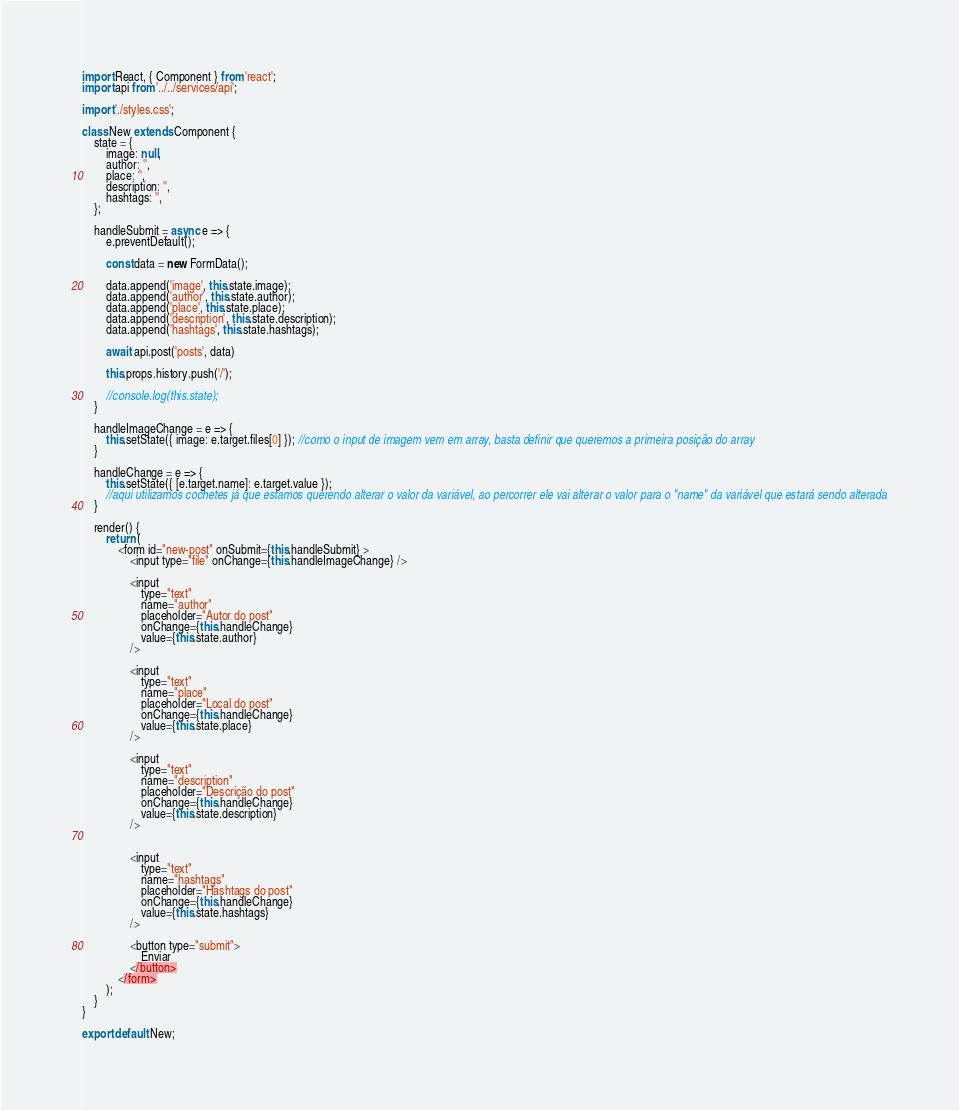Convert code to text. <code><loc_0><loc_0><loc_500><loc_500><_JavaScript_>import React, { Component } from 'react';
import api from '../../services/api';

import './styles.css';

class New extends Component {
    state = {
        image: null,
        author: '',
        place: '',
        description: '',
        hashtags: '',
    };

    handleSubmit = async e => {
        e.preventDefault();

        const data = new FormData();

        data.append('image', this.state.image);
        data.append('author', this.state.author);
        data.append('place', this.state.place);
        data.append('description', this.state.description);
        data.append('hashtags', this.state.hashtags);

        await api.post('posts', data)

        this.props.history.push('/');

        //console.log(this.state);
    }

    handleImageChange = e => {
        this.setState({ image: e.target.files[0] }); //como o input de imagem vem em array, basta definir que queremos a primeira posição do array
    }

    handleChange = e => {
        this.setState({ [e.target.name]: e.target.value }); 
        //aqui utilizamos cochetes já que estamos querendo alterar o valor da variável, ao percorrer ele vai alterar o valor para o "name" da variável que estará sendo alterada
    }

    render() {
        return (
            <form id="new-post" onSubmit={this.handleSubmit} >
                <input type="file" onChange={this.handleImageChange} />

                <input 
                    type="text"
                    name="author"
                    placeholder="Autor do post"
                    onChange={this.handleChange}
                    value={this.state.author}
                />

                <input 
                    type="text"
                    name="place"
                    placeholder="Local do post"
                    onChange={this.handleChange}
                    value={this.state.place}
                />
                
                <input 
                    type="text"
                    name="description"
                    placeholder="Descrição do post"
                    onChange={this.handleChange}
                    value={this.state.description}
                />

                
                <input 
                    type="text"
                    name="hashtags"
                    placeholder="Hashtags do post"
                    onChange={this.handleChange}
                    value={this.state.hashtags}
                />

                <button type="submit">
                    Enviar
                </button>
            </form>
        );
    }
}

export default New;</code> 